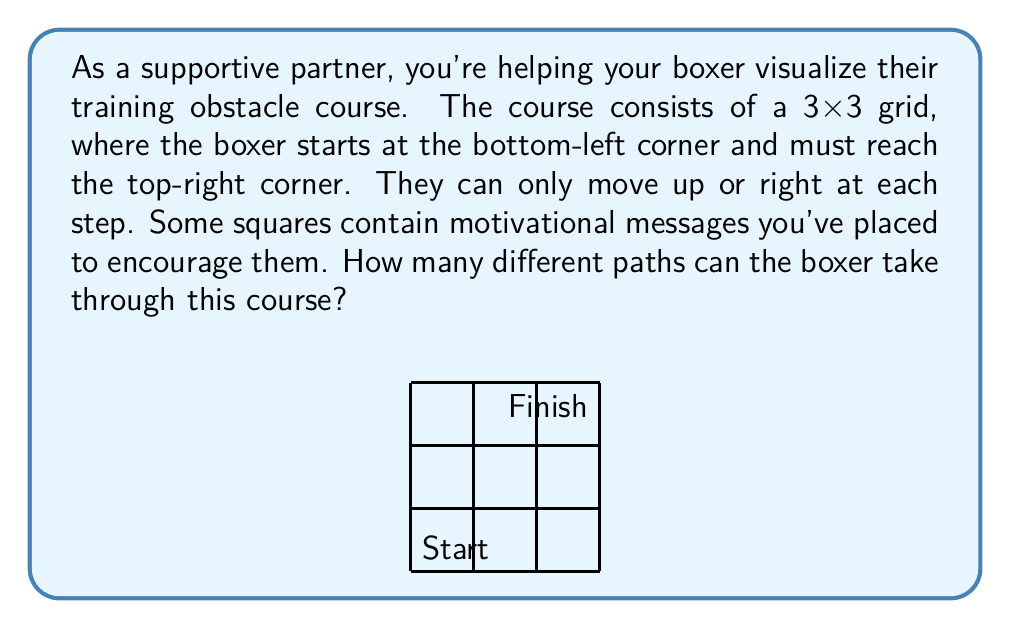What is the answer to this math problem? Let's approach this step-by-step:

1) First, we need to understand what the question is asking. We're looking for the number of paths from the bottom-left corner to the top-right corner, moving only up or right.

2) This is a classic combinatorics problem. To reach the top-right corner, the boxer must make 3 moves to the right and 3 moves up, in any order.

3) The total number of moves is always 6 (3 right + 3 up).

4) The question is essentially asking: in how many ways can we arrange 3 right moves and 3 up moves in a sequence of 6 moves?

5) This is equivalent to choosing which 3 out of the 6 moves will be "right" moves (or equivalently, which 3 will be "up" moves).

6) This is a combination problem. We can use the combination formula:

   $$C(n,r) = \frac{n!}{r!(n-r)!}$$

   where $n$ is the total number of moves (6) and $r$ is the number of right moves (3).

7) Plugging in the numbers:

   $$C(6,3) = \frac{6!}{3!(6-3)!} = \frac{6!}{3!3!}$$

8) Calculating this:
   
   $$\frac{6 * 5 * 4 * 3!}{3! * 3 * 2 * 1} = \frac{6 * 5 * 4}{3 * 2 * 1} = 20$$

Therefore, there are 20 different paths the boxer can take through the course.
Answer: 20 